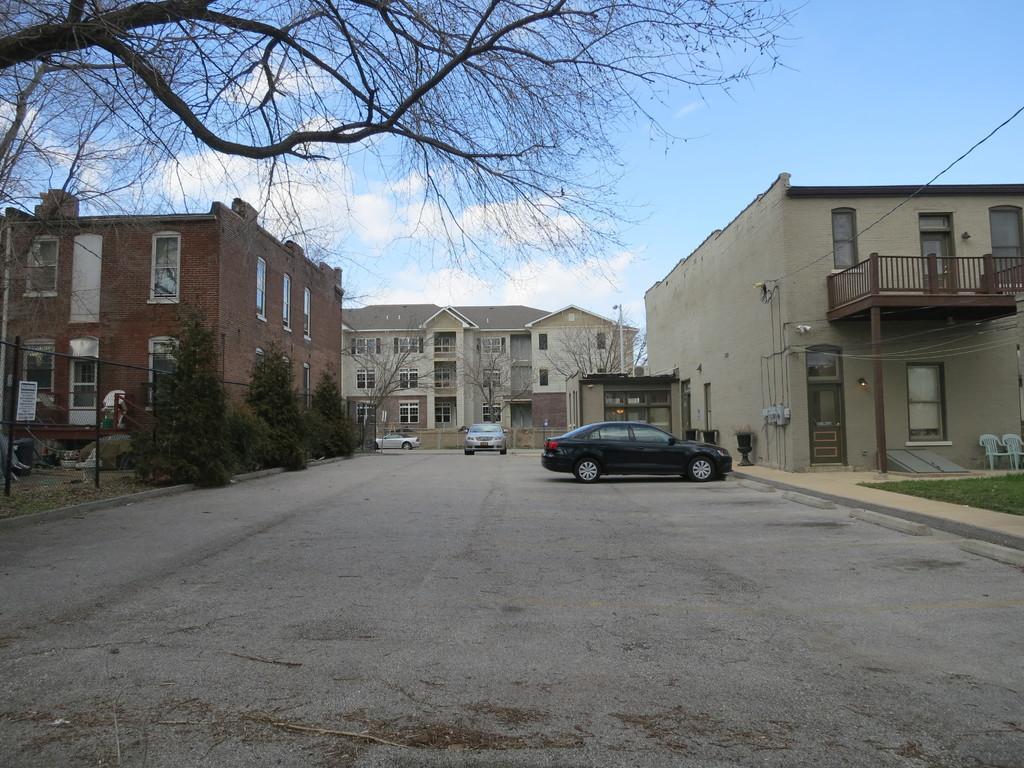How would you summarize this image in a sentence or two? This image is taken outdoors. At the bottom of the image there is a road and three cars are parked on the road. At the top of the image there is a sky with clouds. In the middle of the image there are three buildings with walls, windows, doors, railings, roofs and balconies. There are a few trees and plants. On the right side of the image there are two empty chairs. 